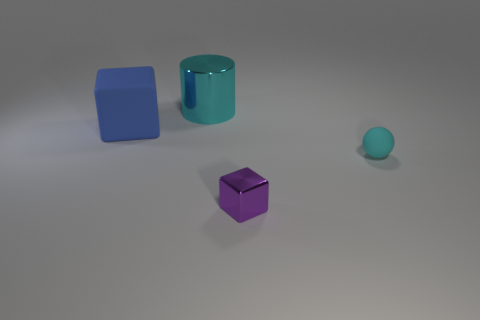Does the cyan metal thing have the same size as the matte block?
Give a very brief answer. Yes. What material is the blue thing?
Keep it short and to the point. Rubber. What is the material of the blue thing that is the same size as the cylinder?
Offer a very short reply. Rubber. Is there another metal thing of the same size as the cyan shiny thing?
Your response must be concise. No. Are there an equal number of objects left of the tiny matte object and large blue matte things that are behind the large cylinder?
Offer a very short reply. No. Are there more small blue cubes than purple metal cubes?
Your response must be concise. No. How many shiny objects are tiny blue objects or tiny purple cubes?
Ensure brevity in your answer.  1. How many shiny objects are the same color as the ball?
Offer a very short reply. 1. What is the material of the cube behind the cyan thing in front of the block behind the small cyan object?
Offer a very short reply. Rubber. What is the color of the matte object to the right of the cyan thing that is to the left of the tiny matte object?
Your answer should be very brief. Cyan. 